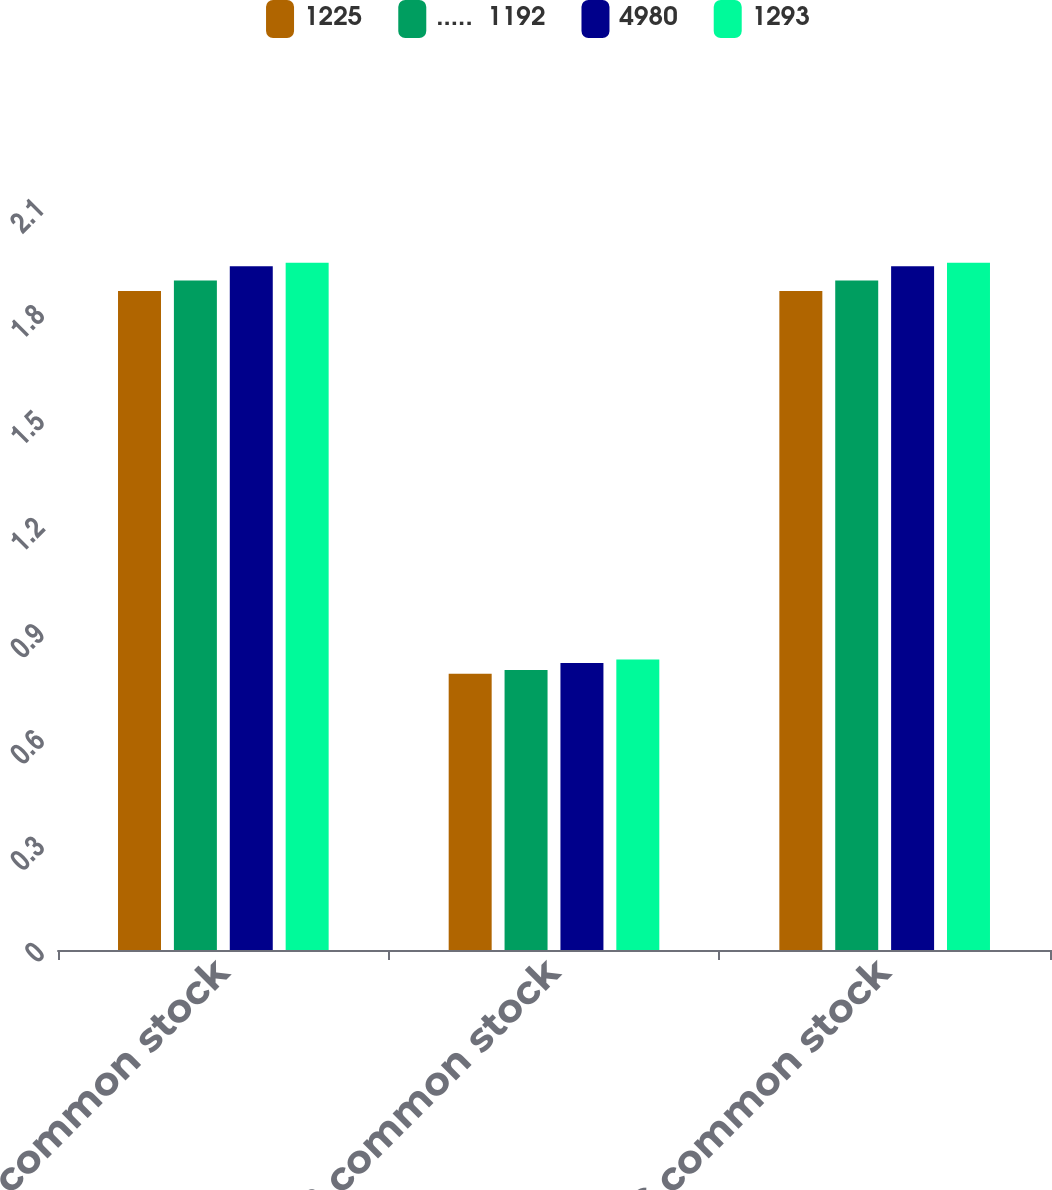Convert chart to OTSL. <chart><loc_0><loc_0><loc_500><loc_500><stacked_bar_chart><ecel><fcel>Class A common stock<fcel>Class B common stock<fcel>Class C common stock<nl><fcel>1225<fcel>1.86<fcel>0.78<fcel>1.86<nl><fcel>.....  1192<fcel>1.89<fcel>0.79<fcel>1.89<nl><fcel>4980<fcel>1.93<fcel>0.81<fcel>1.93<nl><fcel>1293<fcel>1.94<fcel>0.82<fcel>1.94<nl></chart> 